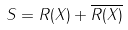Convert formula to latex. <formula><loc_0><loc_0><loc_500><loc_500>S = R ( X ) + \overline { R ( X ) }</formula> 